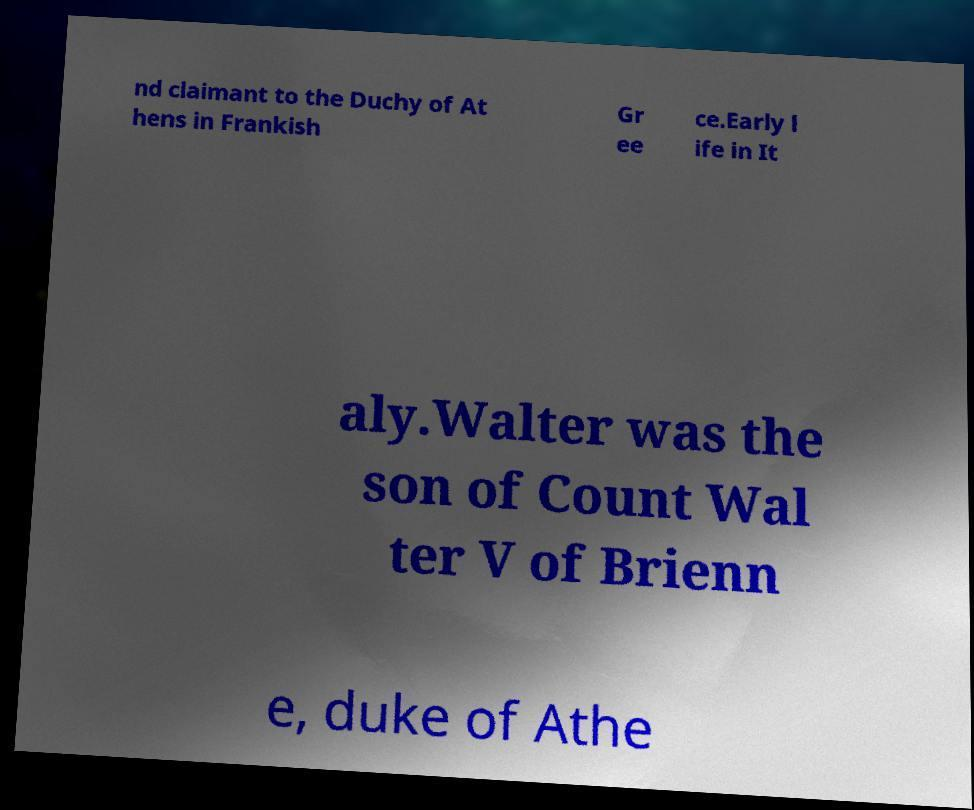Please identify and transcribe the text found in this image. nd claimant to the Duchy of At hens in Frankish Gr ee ce.Early l ife in It aly.Walter was the son of Count Wal ter V of Brienn e, duke of Athe 